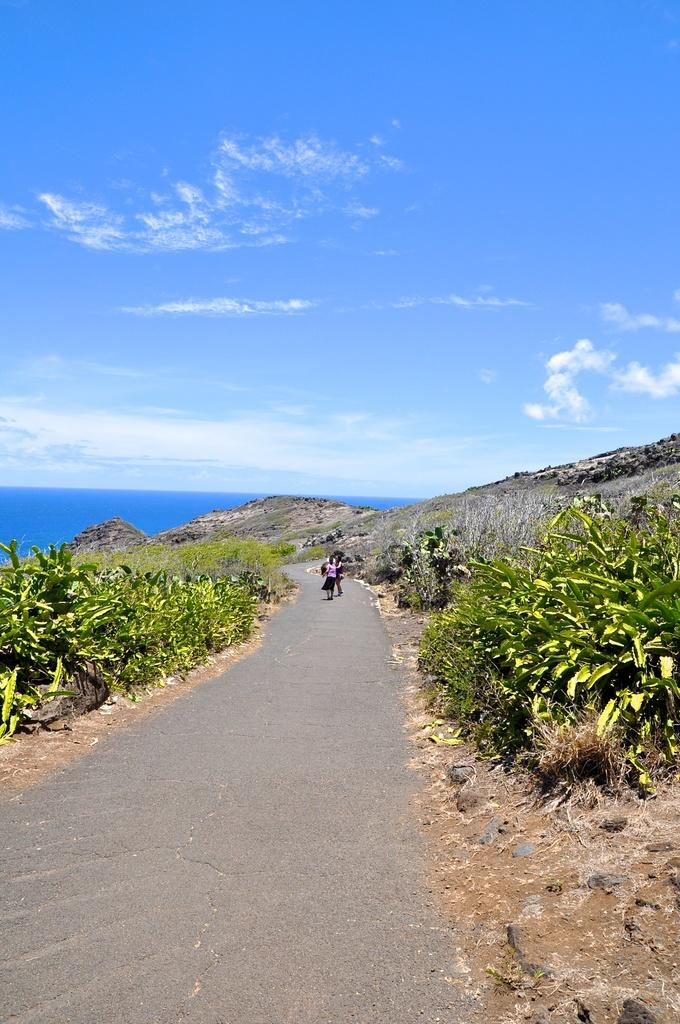What is happening on the road in the image? There are people on the road in the image. What type of vegetation can be seen in the image? There are plants visible in the image. What geographical feature is present in the image? There is a hill in the image. What natural element is visible in the image? There is water visible in the image. What is visible in the sky in the image? There are clouds in the sky in the image. Who is the creator of the machine visible in the image? There is no machine present in the image. What type of substance is being used by the people on the road in the image? The provided facts do not mention any substance being used by the people on the road in the image. 